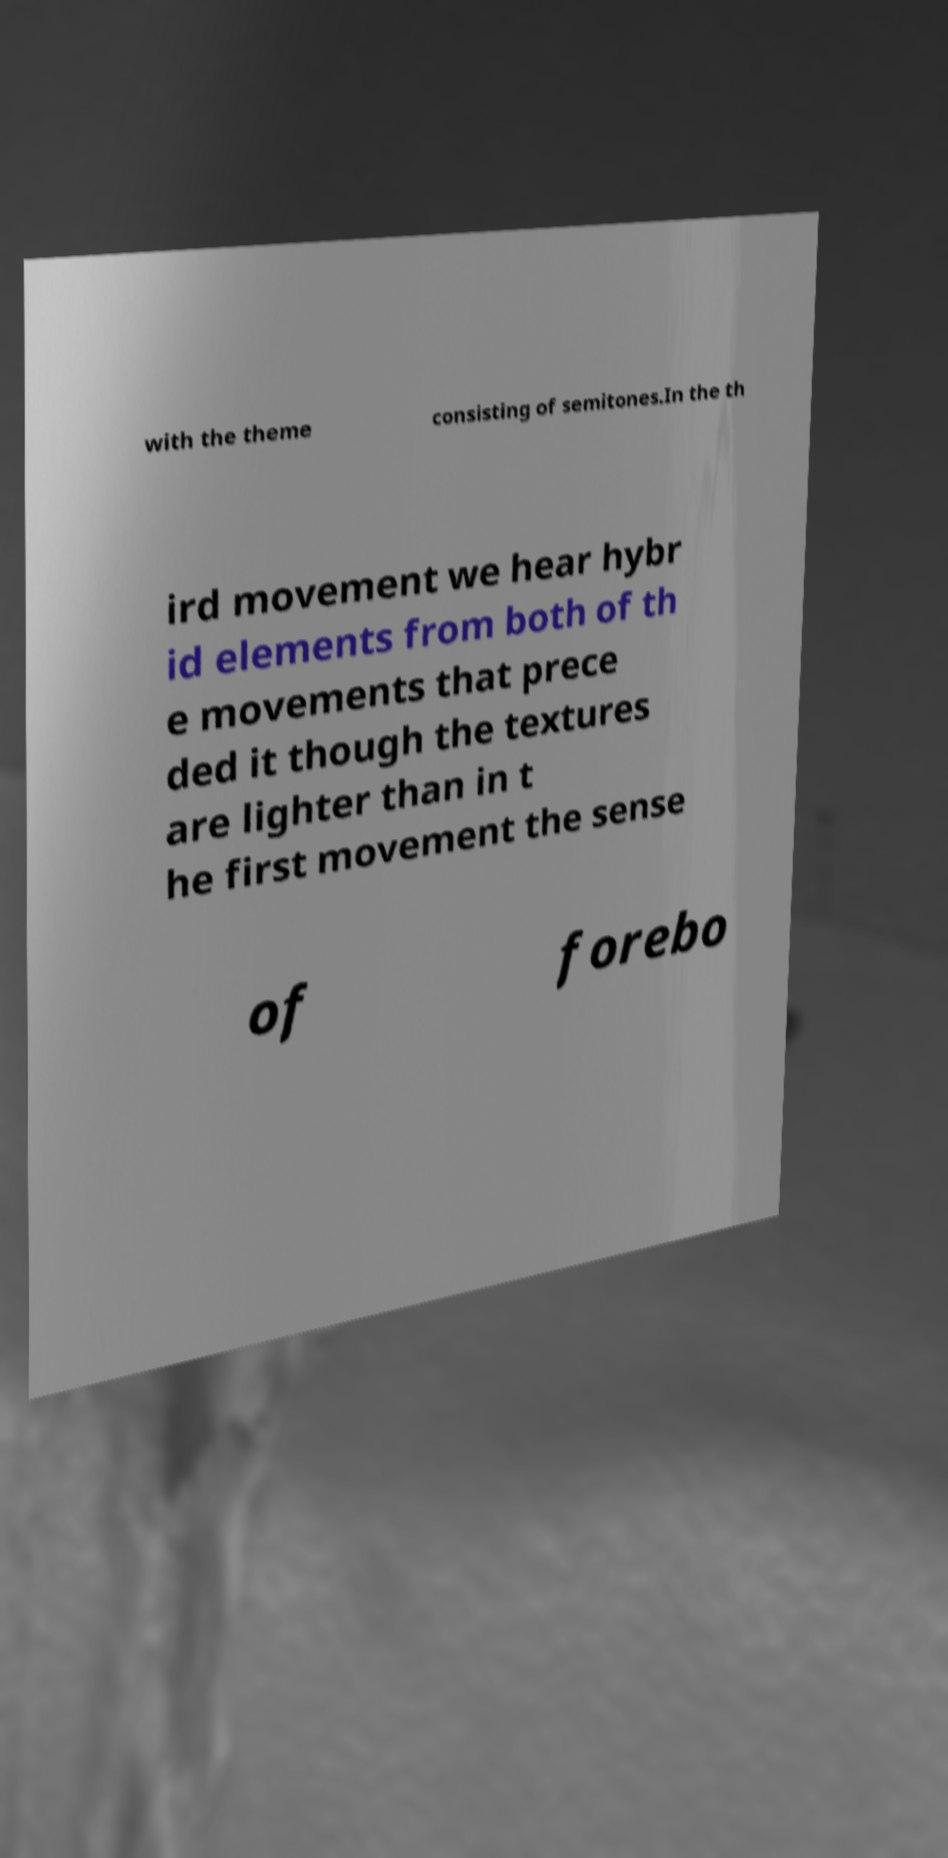There's text embedded in this image that I need extracted. Can you transcribe it verbatim? with the theme consisting of semitones.In the th ird movement we hear hybr id elements from both of th e movements that prece ded it though the textures are lighter than in t he first movement the sense of forebo 